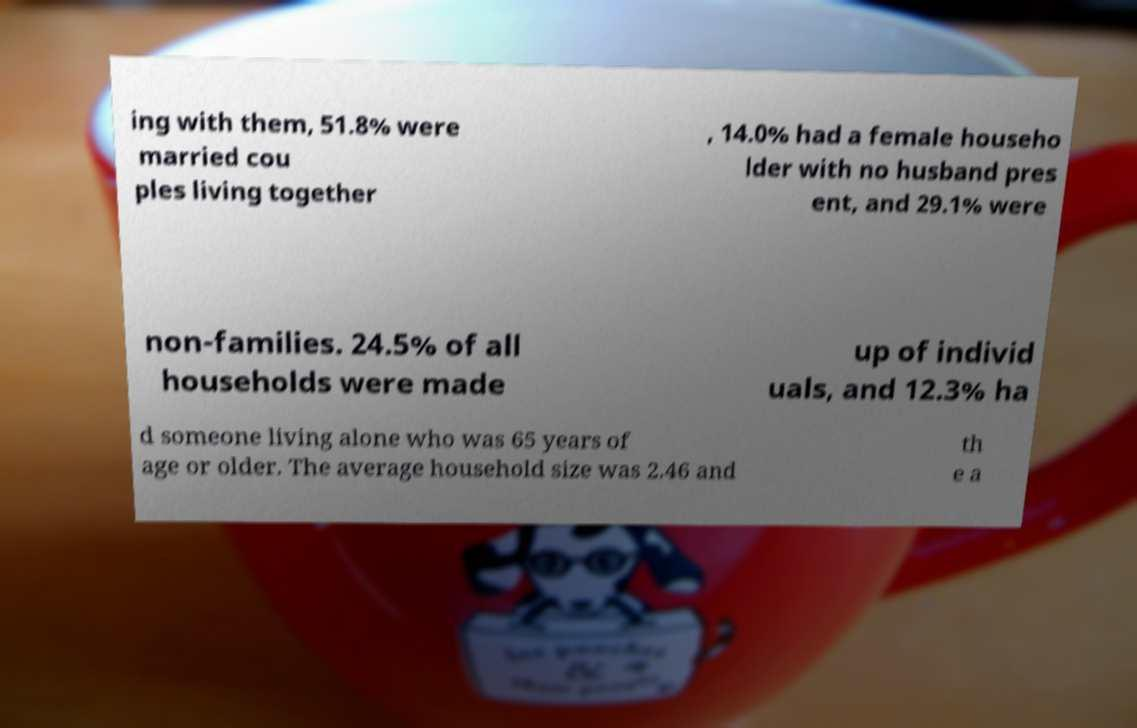Can you accurately transcribe the text from the provided image for me? ing with them, 51.8% were married cou ples living together , 14.0% had a female househo lder with no husband pres ent, and 29.1% were non-families. 24.5% of all households were made up of individ uals, and 12.3% ha d someone living alone who was 65 years of age or older. The average household size was 2.46 and th e a 